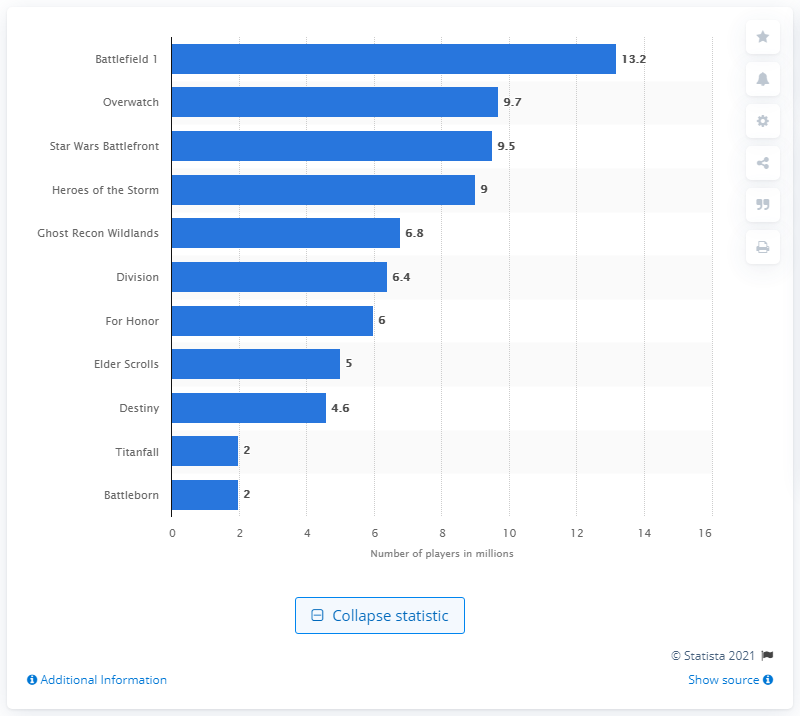Highlight a few significant elements in this photo. Blizzard Entertainment's Overwatch beta version drew a significant number of players, with 9.7... 